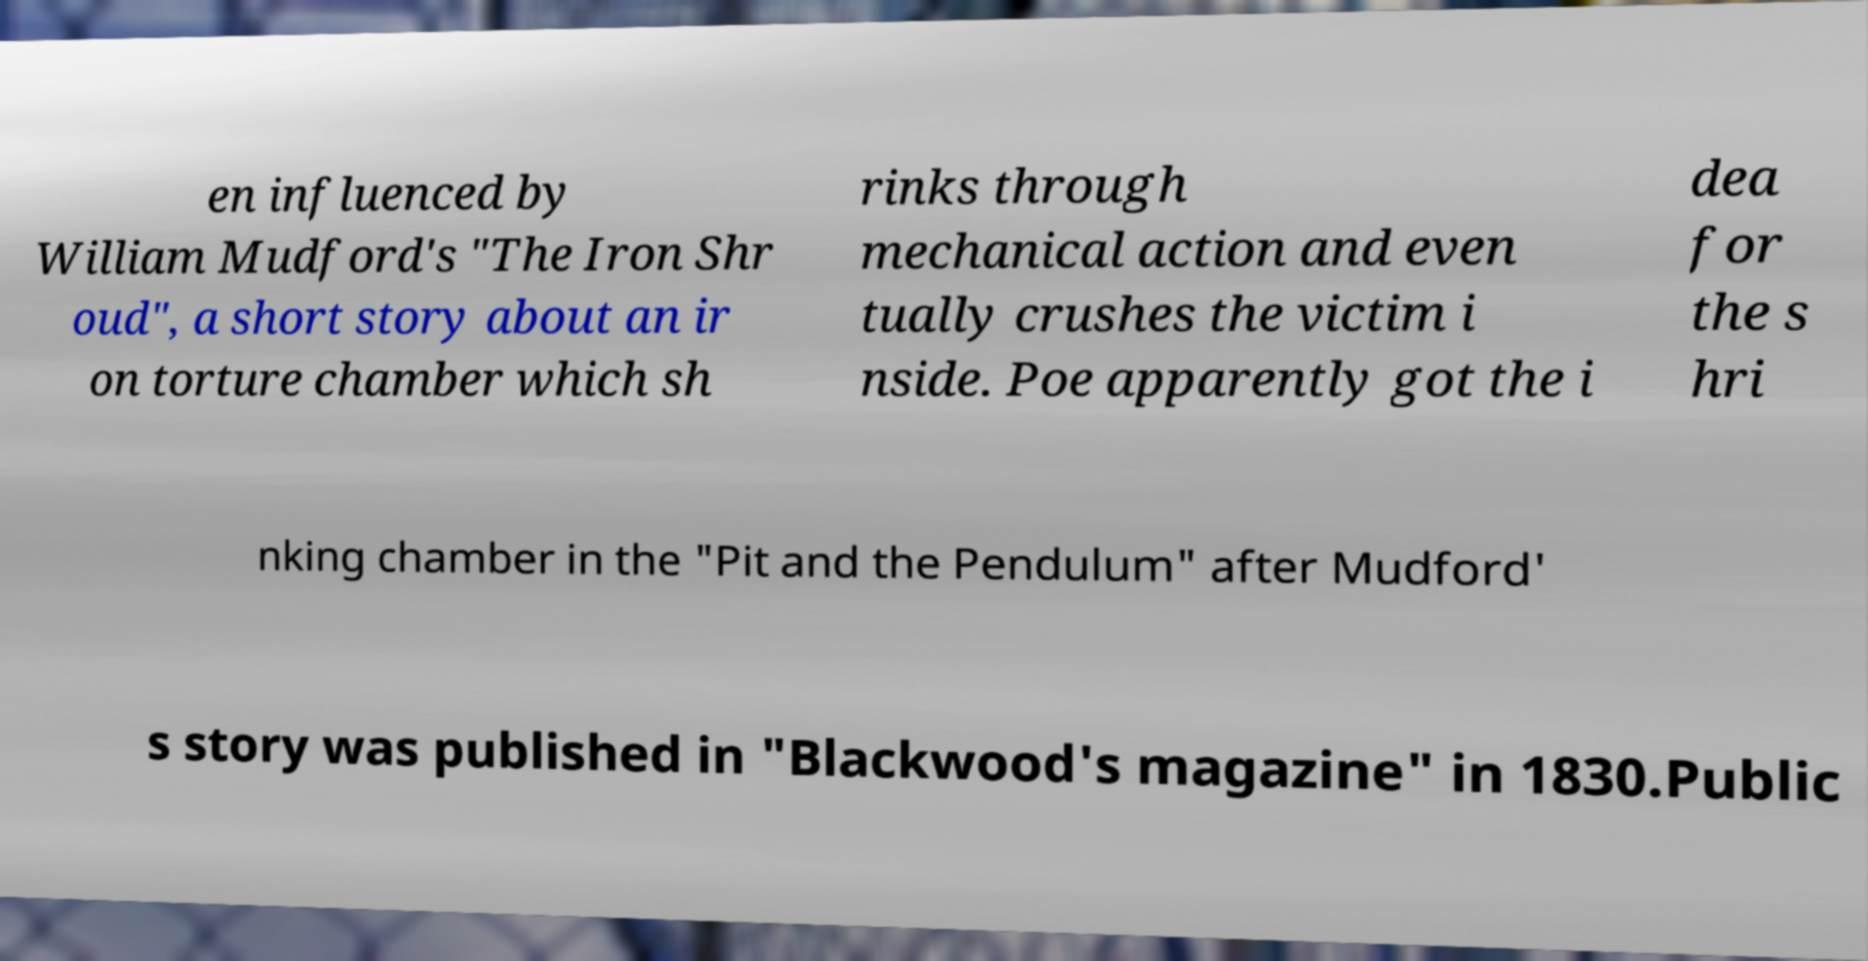Could you extract and type out the text from this image? en influenced by William Mudford's "The Iron Shr oud", a short story about an ir on torture chamber which sh rinks through mechanical action and even tually crushes the victim i nside. Poe apparently got the i dea for the s hri nking chamber in the "Pit and the Pendulum" after Mudford' s story was published in "Blackwood's magazine" in 1830.Public 